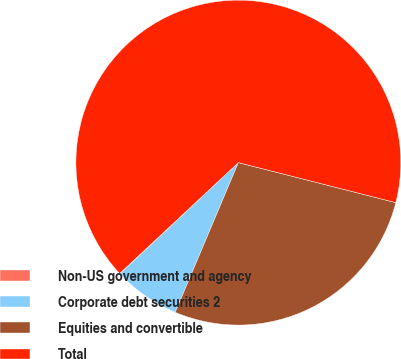<chart> <loc_0><loc_0><loc_500><loc_500><pie_chart><fcel>Non-US government and agency<fcel>Corporate debt securities 2<fcel>Equities and convertible<fcel>Total<nl><fcel>0.05%<fcel>6.64%<fcel>27.39%<fcel>65.92%<nl></chart> 